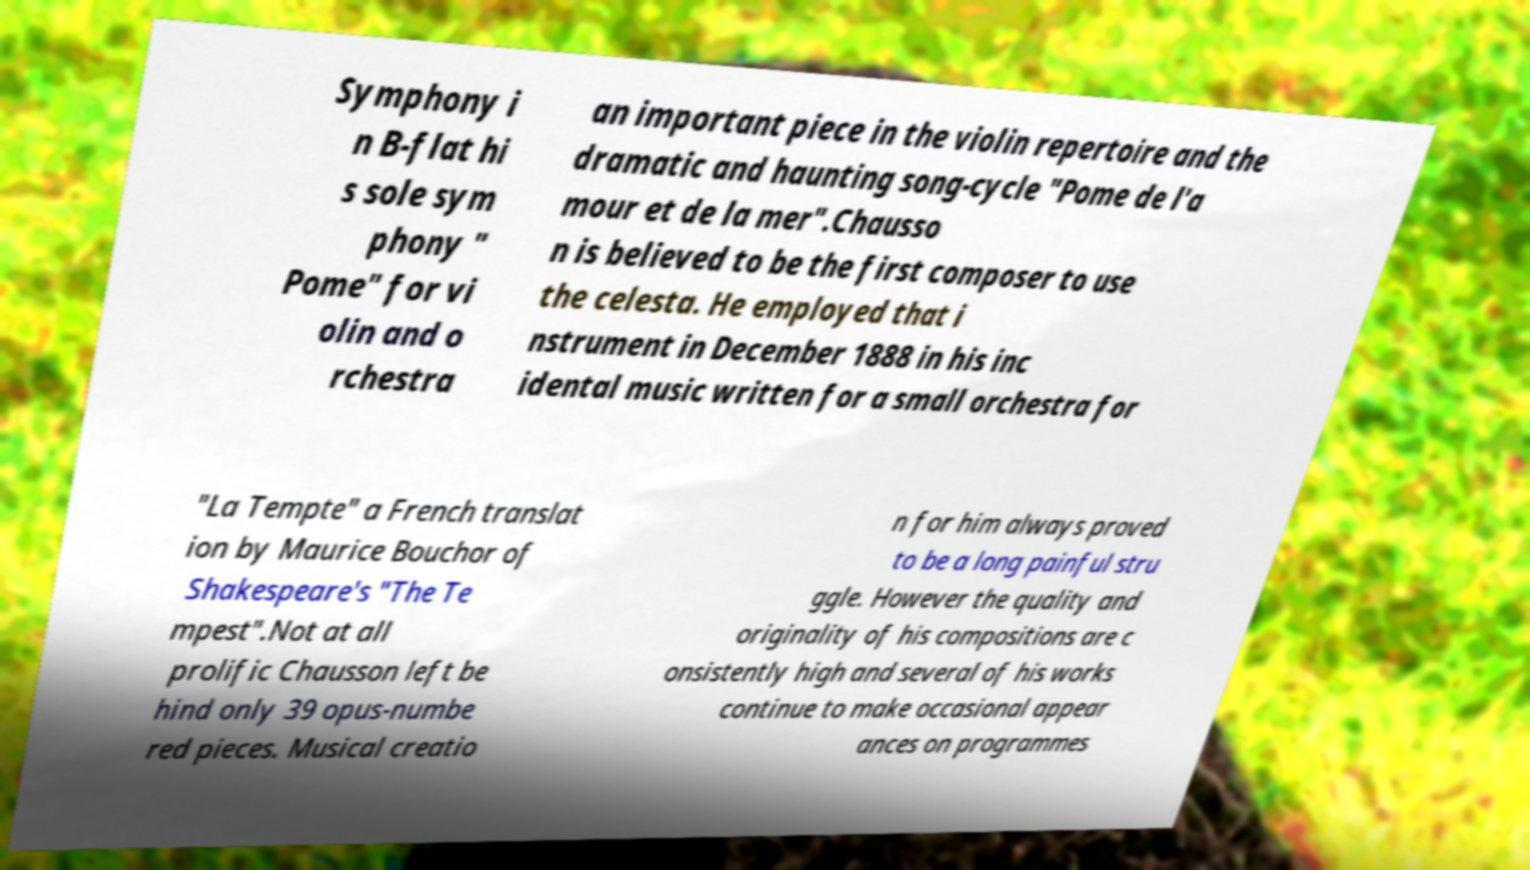Could you extract and type out the text from this image? Symphony i n B-flat hi s sole sym phony " Pome" for vi olin and o rchestra an important piece in the violin repertoire and the dramatic and haunting song-cycle "Pome de l'a mour et de la mer".Chausso n is believed to be the first composer to use the celesta. He employed that i nstrument in December 1888 in his inc idental music written for a small orchestra for "La Tempte" a French translat ion by Maurice Bouchor of Shakespeare's "The Te mpest".Not at all prolific Chausson left be hind only 39 opus-numbe red pieces. Musical creatio n for him always proved to be a long painful stru ggle. However the quality and originality of his compositions are c onsistently high and several of his works continue to make occasional appear ances on programmes 